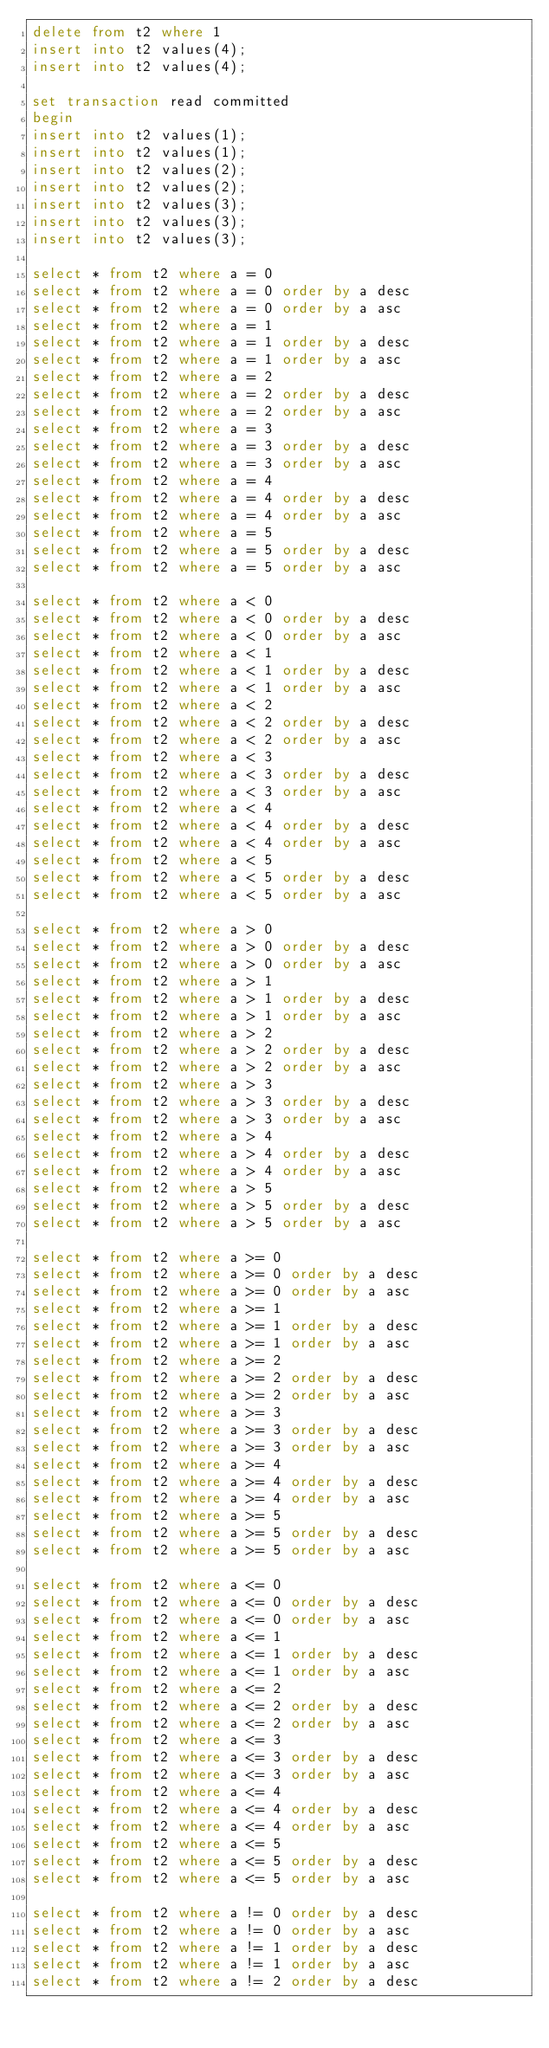Convert code to text. <code><loc_0><loc_0><loc_500><loc_500><_SQL_>delete from t2 where 1
insert into t2 values(4);
insert into t2 values(4);

set transaction read committed
begin
insert into t2 values(1);
insert into t2 values(1);
insert into t2 values(2);
insert into t2 values(2);
insert into t2 values(3);
insert into t2 values(3);
insert into t2 values(3);

select * from t2 where a = 0
select * from t2 where a = 0 order by a desc
select * from t2 where a = 0 order by a asc
select * from t2 where a = 1
select * from t2 where a = 1 order by a desc
select * from t2 where a = 1 order by a asc
select * from t2 where a = 2
select * from t2 where a = 2 order by a desc
select * from t2 where a = 2 order by a asc
select * from t2 where a = 3
select * from t2 where a = 3 order by a desc
select * from t2 where a = 3 order by a asc
select * from t2 where a = 4
select * from t2 where a = 4 order by a desc
select * from t2 where a = 4 order by a asc
select * from t2 where a = 5
select * from t2 where a = 5 order by a desc
select * from t2 where a = 5 order by a asc

select * from t2 where a < 0
select * from t2 where a < 0 order by a desc
select * from t2 where a < 0 order by a asc
select * from t2 where a < 1
select * from t2 where a < 1 order by a desc
select * from t2 where a < 1 order by a asc
select * from t2 where a < 2
select * from t2 where a < 2 order by a desc
select * from t2 where a < 2 order by a asc
select * from t2 where a < 3
select * from t2 where a < 3 order by a desc
select * from t2 where a < 3 order by a asc
select * from t2 where a < 4
select * from t2 where a < 4 order by a desc
select * from t2 where a < 4 order by a asc
select * from t2 where a < 5
select * from t2 where a < 5 order by a desc
select * from t2 where a < 5 order by a asc

select * from t2 where a > 0
select * from t2 where a > 0 order by a desc
select * from t2 where a > 0 order by a asc
select * from t2 where a > 1
select * from t2 where a > 1 order by a desc
select * from t2 where a > 1 order by a asc
select * from t2 where a > 2
select * from t2 where a > 2 order by a desc
select * from t2 where a > 2 order by a asc
select * from t2 where a > 3
select * from t2 where a > 3 order by a desc
select * from t2 where a > 3 order by a asc
select * from t2 where a > 4
select * from t2 where a > 4 order by a desc
select * from t2 where a > 4 order by a asc
select * from t2 where a > 5
select * from t2 where a > 5 order by a desc
select * from t2 where a > 5 order by a asc

select * from t2 where a >= 0
select * from t2 where a >= 0 order by a desc
select * from t2 where a >= 0 order by a asc
select * from t2 where a >= 1
select * from t2 where a >= 1 order by a desc
select * from t2 where a >= 1 order by a asc
select * from t2 where a >= 2
select * from t2 where a >= 2 order by a desc
select * from t2 where a >= 2 order by a asc
select * from t2 where a >= 3
select * from t2 where a >= 3 order by a desc
select * from t2 where a >= 3 order by a asc
select * from t2 where a >= 4
select * from t2 where a >= 4 order by a desc
select * from t2 where a >= 4 order by a asc
select * from t2 where a >= 5
select * from t2 where a >= 5 order by a desc
select * from t2 where a >= 5 order by a asc

select * from t2 where a <= 0
select * from t2 where a <= 0 order by a desc
select * from t2 where a <= 0 order by a asc
select * from t2 where a <= 1
select * from t2 where a <= 1 order by a desc
select * from t2 where a <= 1 order by a asc
select * from t2 where a <= 2
select * from t2 where a <= 2 order by a desc
select * from t2 where a <= 2 order by a asc
select * from t2 where a <= 3
select * from t2 where a <= 3 order by a desc
select * from t2 where a <= 3 order by a asc
select * from t2 where a <= 4
select * from t2 where a <= 4 order by a desc
select * from t2 where a <= 4 order by a asc
select * from t2 where a <= 5
select * from t2 where a <= 5 order by a desc
select * from t2 where a <= 5 order by a asc

select * from t2 where a != 0 order by a desc
select * from t2 where a != 0 order by a asc
select * from t2 where a != 1 order by a desc
select * from t2 where a != 1 order by a asc
select * from t2 where a != 2 order by a desc</code> 